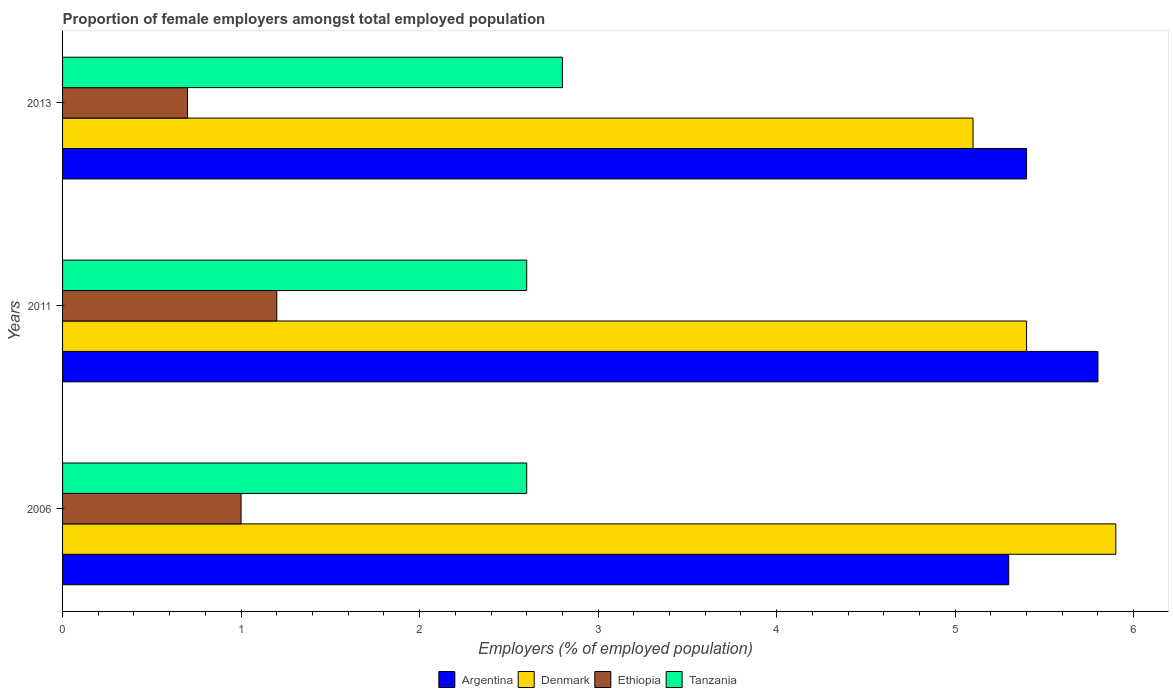How many different coloured bars are there?
Offer a terse response. 4. How many groups of bars are there?
Offer a terse response. 3. Are the number of bars on each tick of the Y-axis equal?
Offer a terse response. Yes. What is the label of the 2nd group of bars from the top?
Offer a very short reply. 2011. What is the proportion of female employers in Ethiopia in 2011?
Your response must be concise. 1.2. Across all years, what is the maximum proportion of female employers in Tanzania?
Make the answer very short. 2.8. Across all years, what is the minimum proportion of female employers in Denmark?
Your response must be concise. 5.1. What is the total proportion of female employers in Denmark in the graph?
Your answer should be compact. 16.4. What is the difference between the proportion of female employers in Tanzania in 2006 and that in 2013?
Your answer should be very brief. -0.2. What is the difference between the proportion of female employers in Tanzania in 2006 and the proportion of female employers in Ethiopia in 2013?
Keep it short and to the point. 1.9. What is the average proportion of female employers in Tanzania per year?
Give a very brief answer. 2.67. In the year 2011, what is the difference between the proportion of female employers in Tanzania and proportion of female employers in Denmark?
Ensure brevity in your answer.  -2.8. What is the ratio of the proportion of female employers in Denmark in 2011 to that in 2013?
Make the answer very short. 1.06. Is the proportion of female employers in Denmark in 2011 less than that in 2013?
Keep it short and to the point. No. What is the difference between the highest and the second highest proportion of female employers in Ethiopia?
Give a very brief answer. 0.2. What is the difference between the highest and the lowest proportion of female employers in Tanzania?
Your answer should be compact. 0.2. Is it the case that in every year, the sum of the proportion of female employers in Argentina and proportion of female employers in Tanzania is greater than the sum of proportion of female employers in Denmark and proportion of female employers in Ethiopia?
Your answer should be very brief. No. What does the 2nd bar from the bottom in 2013 represents?
Provide a short and direct response. Denmark. Is it the case that in every year, the sum of the proportion of female employers in Denmark and proportion of female employers in Argentina is greater than the proportion of female employers in Tanzania?
Your answer should be very brief. Yes. What is the difference between two consecutive major ticks on the X-axis?
Offer a very short reply. 1. Does the graph contain any zero values?
Your answer should be compact. No. How many legend labels are there?
Provide a succinct answer. 4. What is the title of the graph?
Give a very brief answer. Proportion of female employers amongst total employed population. What is the label or title of the X-axis?
Provide a short and direct response. Employers (% of employed population). What is the Employers (% of employed population) of Argentina in 2006?
Ensure brevity in your answer.  5.3. What is the Employers (% of employed population) of Denmark in 2006?
Offer a terse response. 5.9. What is the Employers (% of employed population) in Tanzania in 2006?
Your answer should be compact. 2.6. What is the Employers (% of employed population) in Argentina in 2011?
Provide a short and direct response. 5.8. What is the Employers (% of employed population) in Denmark in 2011?
Make the answer very short. 5.4. What is the Employers (% of employed population) in Ethiopia in 2011?
Your answer should be very brief. 1.2. What is the Employers (% of employed population) of Tanzania in 2011?
Offer a terse response. 2.6. What is the Employers (% of employed population) in Argentina in 2013?
Your answer should be very brief. 5.4. What is the Employers (% of employed population) of Denmark in 2013?
Provide a succinct answer. 5.1. What is the Employers (% of employed population) of Ethiopia in 2013?
Offer a terse response. 0.7. What is the Employers (% of employed population) in Tanzania in 2013?
Make the answer very short. 2.8. Across all years, what is the maximum Employers (% of employed population) in Argentina?
Ensure brevity in your answer.  5.8. Across all years, what is the maximum Employers (% of employed population) in Denmark?
Keep it short and to the point. 5.9. Across all years, what is the maximum Employers (% of employed population) in Ethiopia?
Provide a short and direct response. 1.2. Across all years, what is the maximum Employers (% of employed population) in Tanzania?
Offer a very short reply. 2.8. Across all years, what is the minimum Employers (% of employed population) of Argentina?
Make the answer very short. 5.3. Across all years, what is the minimum Employers (% of employed population) in Denmark?
Your response must be concise. 5.1. Across all years, what is the minimum Employers (% of employed population) in Ethiopia?
Make the answer very short. 0.7. Across all years, what is the minimum Employers (% of employed population) of Tanzania?
Your response must be concise. 2.6. What is the total Employers (% of employed population) in Ethiopia in the graph?
Offer a very short reply. 2.9. What is the difference between the Employers (% of employed population) of Ethiopia in 2006 and that in 2011?
Provide a succinct answer. -0.2. What is the difference between the Employers (% of employed population) in Denmark in 2006 and that in 2013?
Ensure brevity in your answer.  0.8. What is the difference between the Employers (% of employed population) of Tanzania in 2006 and that in 2013?
Give a very brief answer. -0.2. What is the difference between the Employers (% of employed population) in Argentina in 2006 and the Employers (% of employed population) in Ethiopia in 2011?
Ensure brevity in your answer.  4.1. What is the difference between the Employers (% of employed population) of Argentina in 2006 and the Employers (% of employed population) of Tanzania in 2011?
Offer a terse response. 2.7. What is the difference between the Employers (% of employed population) of Denmark in 2006 and the Employers (% of employed population) of Ethiopia in 2011?
Provide a succinct answer. 4.7. What is the difference between the Employers (% of employed population) in Ethiopia in 2006 and the Employers (% of employed population) in Tanzania in 2011?
Ensure brevity in your answer.  -1.6. What is the difference between the Employers (% of employed population) in Argentina in 2006 and the Employers (% of employed population) in Denmark in 2013?
Ensure brevity in your answer.  0.2. What is the difference between the Employers (% of employed population) of Argentina in 2006 and the Employers (% of employed population) of Ethiopia in 2013?
Offer a terse response. 4.6. What is the difference between the Employers (% of employed population) of Denmark in 2006 and the Employers (% of employed population) of Ethiopia in 2013?
Make the answer very short. 5.2. What is the difference between the Employers (% of employed population) in Argentina in 2011 and the Employers (% of employed population) in Ethiopia in 2013?
Ensure brevity in your answer.  5.1. What is the difference between the Employers (% of employed population) in Argentina in 2011 and the Employers (% of employed population) in Tanzania in 2013?
Your response must be concise. 3. What is the difference between the Employers (% of employed population) of Denmark in 2011 and the Employers (% of employed population) of Tanzania in 2013?
Offer a very short reply. 2.6. What is the difference between the Employers (% of employed population) in Ethiopia in 2011 and the Employers (% of employed population) in Tanzania in 2013?
Provide a succinct answer. -1.6. What is the average Employers (% of employed population) of Argentina per year?
Provide a short and direct response. 5.5. What is the average Employers (% of employed population) of Denmark per year?
Offer a very short reply. 5.47. What is the average Employers (% of employed population) of Ethiopia per year?
Offer a terse response. 0.97. What is the average Employers (% of employed population) in Tanzania per year?
Give a very brief answer. 2.67. In the year 2006, what is the difference between the Employers (% of employed population) of Argentina and Employers (% of employed population) of Denmark?
Give a very brief answer. -0.6. In the year 2006, what is the difference between the Employers (% of employed population) of Denmark and Employers (% of employed population) of Ethiopia?
Offer a very short reply. 4.9. In the year 2006, what is the difference between the Employers (% of employed population) of Denmark and Employers (% of employed population) of Tanzania?
Offer a terse response. 3.3. In the year 2011, what is the difference between the Employers (% of employed population) in Argentina and Employers (% of employed population) in Ethiopia?
Your response must be concise. 4.6. In the year 2011, what is the difference between the Employers (% of employed population) of Argentina and Employers (% of employed population) of Tanzania?
Ensure brevity in your answer.  3.2. In the year 2011, what is the difference between the Employers (% of employed population) of Denmark and Employers (% of employed population) of Ethiopia?
Give a very brief answer. 4.2. In the year 2013, what is the difference between the Employers (% of employed population) in Argentina and Employers (% of employed population) in Ethiopia?
Offer a very short reply. 4.7. In the year 2013, what is the difference between the Employers (% of employed population) in Denmark and Employers (% of employed population) in Tanzania?
Provide a short and direct response. 2.3. What is the ratio of the Employers (% of employed population) of Argentina in 2006 to that in 2011?
Offer a terse response. 0.91. What is the ratio of the Employers (% of employed population) in Denmark in 2006 to that in 2011?
Your answer should be compact. 1.09. What is the ratio of the Employers (% of employed population) in Ethiopia in 2006 to that in 2011?
Your answer should be compact. 0.83. What is the ratio of the Employers (% of employed population) in Argentina in 2006 to that in 2013?
Provide a short and direct response. 0.98. What is the ratio of the Employers (% of employed population) of Denmark in 2006 to that in 2013?
Offer a terse response. 1.16. What is the ratio of the Employers (% of employed population) in Ethiopia in 2006 to that in 2013?
Your response must be concise. 1.43. What is the ratio of the Employers (% of employed population) of Tanzania in 2006 to that in 2013?
Ensure brevity in your answer.  0.93. What is the ratio of the Employers (% of employed population) of Argentina in 2011 to that in 2013?
Keep it short and to the point. 1.07. What is the ratio of the Employers (% of employed population) in Denmark in 2011 to that in 2013?
Make the answer very short. 1.06. What is the ratio of the Employers (% of employed population) in Ethiopia in 2011 to that in 2013?
Give a very brief answer. 1.71. What is the difference between the highest and the second highest Employers (% of employed population) of Denmark?
Your answer should be very brief. 0.5. What is the difference between the highest and the second highest Employers (% of employed population) in Ethiopia?
Ensure brevity in your answer.  0.2. What is the difference between the highest and the second highest Employers (% of employed population) of Tanzania?
Provide a succinct answer. 0.2. What is the difference between the highest and the lowest Employers (% of employed population) of Argentina?
Give a very brief answer. 0.5. What is the difference between the highest and the lowest Employers (% of employed population) in Ethiopia?
Make the answer very short. 0.5. What is the difference between the highest and the lowest Employers (% of employed population) of Tanzania?
Your response must be concise. 0.2. 